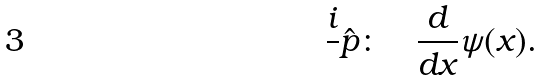Convert formula to latex. <formula><loc_0><loc_0><loc_500><loc_500>\frac { i } { } \hat { p } \colon \quad \frac { d } { d x } \psi ( x ) .</formula> 